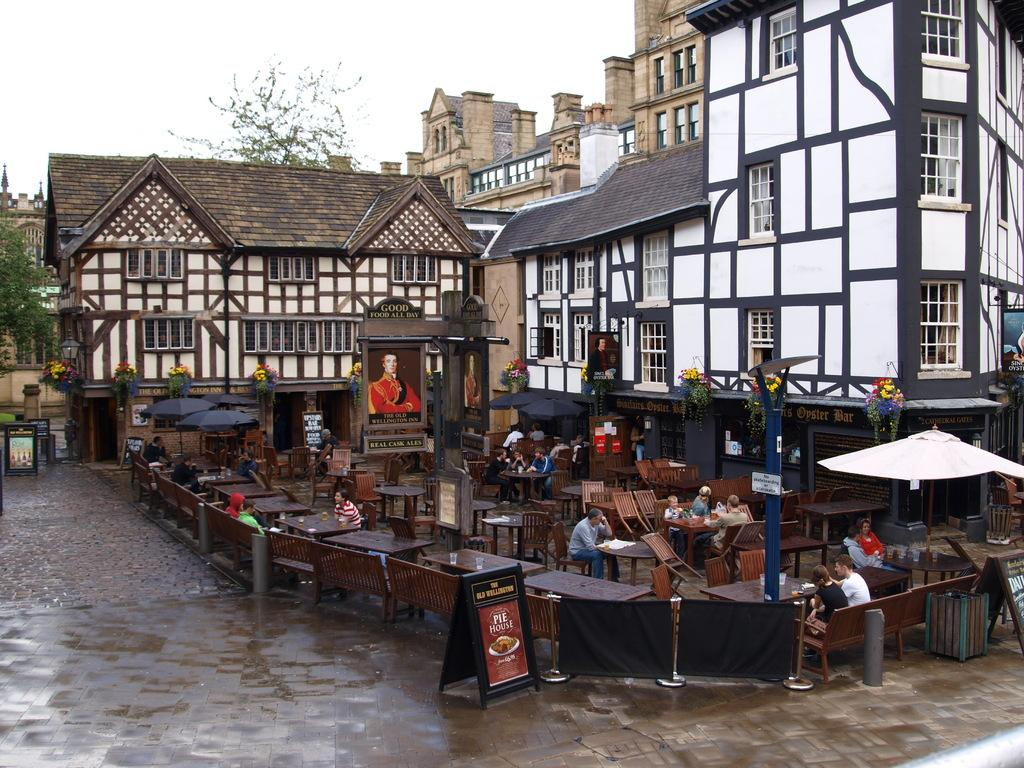Provide a one-sentence caption for the provided image. A sign sits outside the Old Wellington advertising its famous Pie House. 